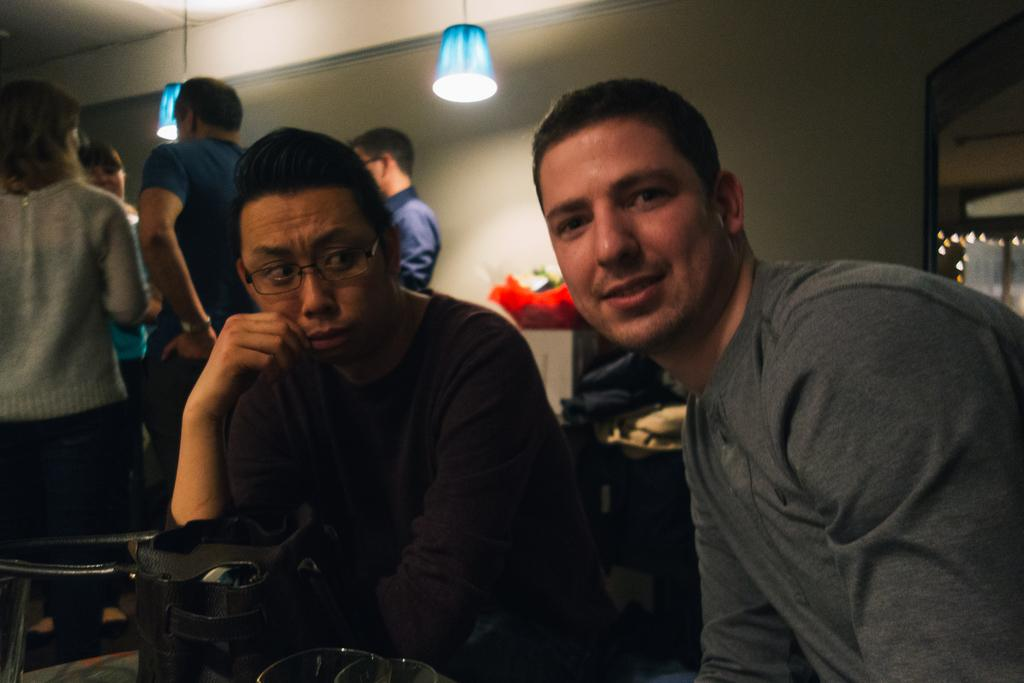How many people are in the image? There are few persons in the image. What object can be seen in the image that is typically used for carrying items? There is a bag in the image. What objects can be seen in the image that are used for seeing? There are glasses in the image. What type of illumination is present in the image? There are lights in the image. What can be seen in the background of the image? There is a wall in the background of the image. What type of body of water can be seen in the image? There is no body of water present in the image; it features a few persons, a bag, glasses, lights, and a wall in the background. 